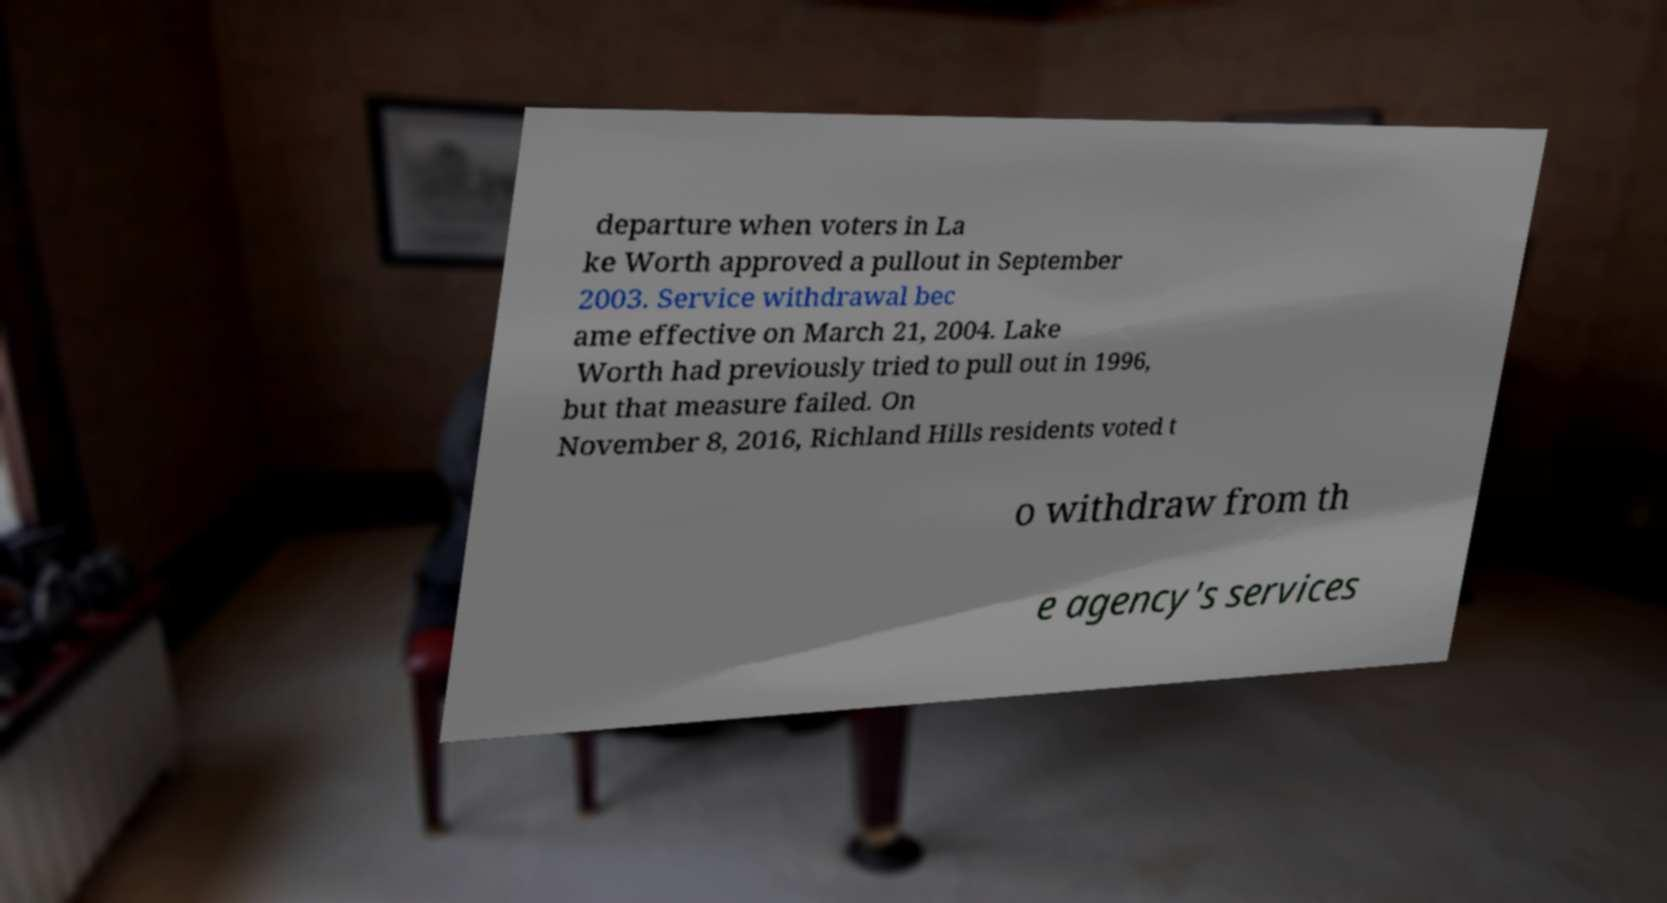Please read and relay the text visible in this image. What does it say? departure when voters in La ke Worth approved a pullout in September 2003. Service withdrawal bec ame effective on March 21, 2004. Lake Worth had previously tried to pull out in 1996, but that measure failed. On November 8, 2016, Richland Hills residents voted t o withdraw from th e agency's services 